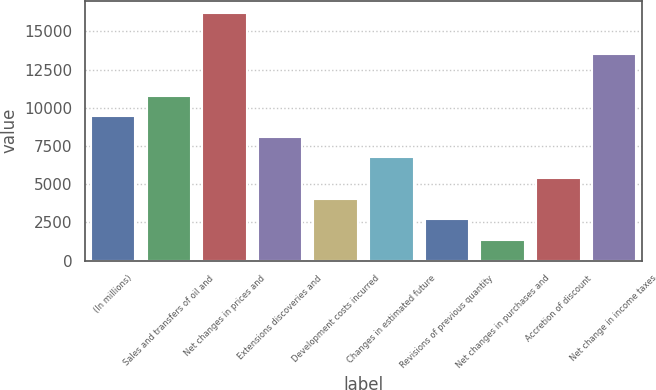<chart> <loc_0><loc_0><loc_500><loc_500><bar_chart><fcel>(In millions)<fcel>Sales and transfers of oil and<fcel>Net changes in prices and<fcel>Extensions discoveries and<fcel>Development costs incurred<fcel>Changes in estimated future<fcel>Revisions of previous quantity<fcel>Net changes in purchases and<fcel>Accretion of discount<fcel>Net change in income taxes<nl><fcel>9450.1<fcel>10798.4<fcel>16191.6<fcel>8101.8<fcel>4056.9<fcel>6753.5<fcel>2708.6<fcel>1360.3<fcel>5405.2<fcel>13495<nl></chart> 